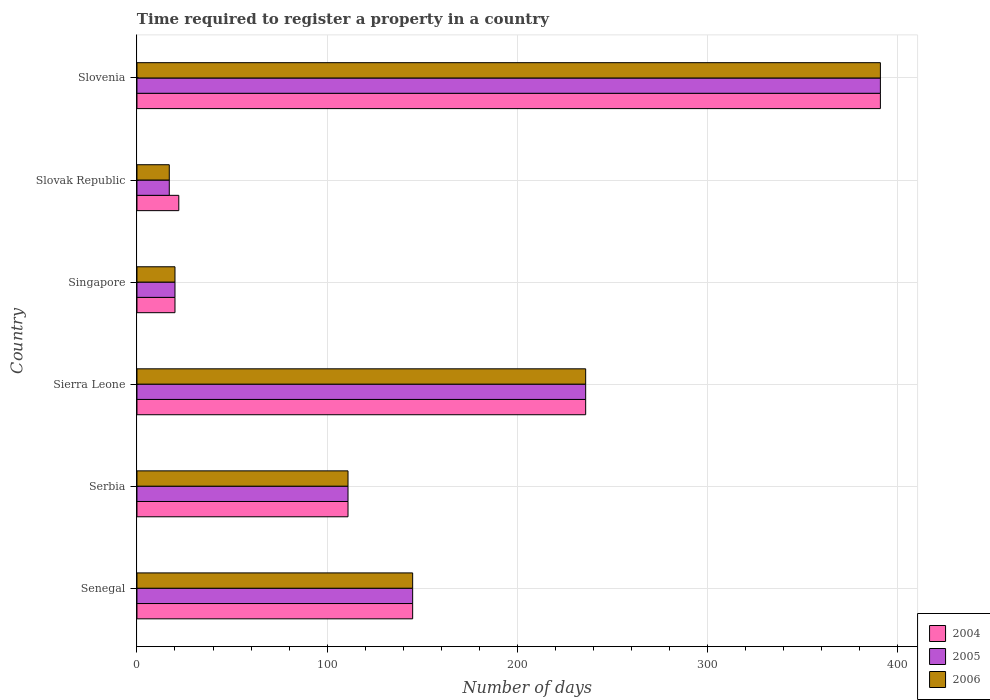Are the number of bars on each tick of the Y-axis equal?
Make the answer very short. Yes. How many bars are there on the 6th tick from the top?
Your response must be concise. 3. How many bars are there on the 3rd tick from the bottom?
Offer a very short reply. 3. What is the label of the 1st group of bars from the top?
Ensure brevity in your answer.  Slovenia. In how many cases, is the number of bars for a given country not equal to the number of legend labels?
Provide a short and direct response. 0. What is the number of days required to register a property in 2006 in Sierra Leone?
Provide a succinct answer. 236. Across all countries, what is the maximum number of days required to register a property in 2004?
Your answer should be very brief. 391. In which country was the number of days required to register a property in 2006 maximum?
Offer a terse response. Slovenia. In which country was the number of days required to register a property in 2005 minimum?
Your answer should be compact. Slovak Republic. What is the total number of days required to register a property in 2004 in the graph?
Your answer should be compact. 925. What is the difference between the number of days required to register a property in 2005 in Serbia and that in Slovenia?
Ensure brevity in your answer.  -280. What is the difference between the number of days required to register a property in 2005 in Serbia and the number of days required to register a property in 2004 in Senegal?
Give a very brief answer. -34. What is the average number of days required to register a property in 2004 per country?
Provide a short and direct response. 154.17. What is the ratio of the number of days required to register a property in 2004 in Sierra Leone to that in Slovenia?
Provide a short and direct response. 0.6. Is the number of days required to register a property in 2006 in Serbia less than that in Singapore?
Provide a short and direct response. No. Is the difference between the number of days required to register a property in 2006 in Singapore and Slovak Republic greater than the difference between the number of days required to register a property in 2004 in Singapore and Slovak Republic?
Ensure brevity in your answer.  Yes. What is the difference between the highest and the second highest number of days required to register a property in 2006?
Make the answer very short. 155. What is the difference between the highest and the lowest number of days required to register a property in 2004?
Provide a succinct answer. 371. In how many countries, is the number of days required to register a property in 2006 greater than the average number of days required to register a property in 2006 taken over all countries?
Your answer should be very brief. 2. Is the sum of the number of days required to register a property in 2006 in Serbia and Slovenia greater than the maximum number of days required to register a property in 2004 across all countries?
Keep it short and to the point. Yes. What does the 1st bar from the top in Slovak Republic represents?
Make the answer very short. 2006. Is it the case that in every country, the sum of the number of days required to register a property in 2004 and number of days required to register a property in 2006 is greater than the number of days required to register a property in 2005?
Make the answer very short. Yes. How many bars are there?
Your answer should be compact. 18. Are all the bars in the graph horizontal?
Offer a terse response. Yes. What is the difference between two consecutive major ticks on the X-axis?
Make the answer very short. 100. Does the graph contain any zero values?
Make the answer very short. No. Does the graph contain grids?
Your response must be concise. Yes. How many legend labels are there?
Your answer should be compact. 3. What is the title of the graph?
Keep it short and to the point. Time required to register a property in a country. Does "1973" appear as one of the legend labels in the graph?
Make the answer very short. No. What is the label or title of the X-axis?
Provide a short and direct response. Number of days. What is the label or title of the Y-axis?
Offer a very short reply. Country. What is the Number of days of 2004 in Senegal?
Offer a terse response. 145. What is the Number of days in 2005 in Senegal?
Provide a succinct answer. 145. What is the Number of days in 2006 in Senegal?
Your answer should be compact. 145. What is the Number of days of 2004 in Serbia?
Make the answer very short. 111. What is the Number of days of 2005 in Serbia?
Ensure brevity in your answer.  111. What is the Number of days of 2006 in Serbia?
Make the answer very short. 111. What is the Number of days of 2004 in Sierra Leone?
Your answer should be very brief. 236. What is the Number of days of 2005 in Sierra Leone?
Give a very brief answer. 236. What is the Number of days in 2006 in Sierra Leone?
Keep it short and to the point. 236. What is the Number of days in 2006 in Singapore?
Provide a succinct answer. 20. What is the Number of days in 2004 in Slovenia?
Provide a short and direct response. 391. What is the Number of days in 2005 in Slovenia?
Ensure brevity in your answer.  391. What is the Number of days in 2006 in Slovenia?
Your response must be concise. 391. Across all countries, what is the maximum Number of days of 2004?
Offer a terse response. 391. Across all countries, what is the maximum Number of days of 2005?
Make the answer very short. 391. Across all countries, what is the maximum Number of days in 2006?
Keep it short and to the point. 391. Across all countries, what is the minimum Number of days of 2004?
Provide a short and direct response. 20. What is the total Number of days of 2004 in the graph?
Offer a terse response. 925. What is the total Number of days in 2005 in the graph?
Offer a very short reply. 920. What is the total Number of days in 2006 in the graph?
Your response must be concise. 920. What is the difference between the Number of days in 2004 in Senegal and that in Serbia?
Ensure brevity in your answer.  34. What is the difference between the Number of days in 2004 in Senegal and that in Sierra Leone?
Your answer should be very brief. -91. What is the difference between the Number of days of 2005 in Senegal and that in Sierra Leone?
Your response must be concise. -91. What is the difference between the Number of days of 2006 in Senegal and that in Sierra Leone?
Offer a terse response. -91. What is the difference between the Number of days in 2004 in Senegal and that in Singapore?
Offer a terse response. 125. What is the difference between the Number of days of 2005 in Senegal and that in Singapore?
Offer a terse response. 125. What is the difference between the Number of days in 2006 in Senegal and that in Singapore?
Provide a succinct answer. 125. What is the difference between the Number of days of 2004 in Senegal and that in Slovak Republic?
Give a very brief answer. 123. What is the difference between the Number of days in 2005 in Senegal and that in Slovak Republic?
Give a very brief answer. 128. What is the difference between the Number of days in 2006 in Senegal and that in Slovak Republic?
Your answer should be compact. 128. What is the difference between the Number of days of 2004 in Senegal and that in Slovenia?
Make the answer very short. -246. What is the difference between the Number of days of 2005 in Senegal and that in Slovenia?
Ensure brevity in your answer.  -246. What is the difference between the Number of days of 2006 in Senegal and that in Slovenia?
Give a very brief answer. -246. What is the difference between the Number of days of 2004 in Serbia and that in Sierra Leone?
Your answer should be very brief. -125. What is the difference between the Number of days in 2005 in Serbia and that in Sierra Leone?
Your answer should be very brief. -125. What is the difference between the Number of days of 2006 in Serbia and that in Sierra Leone?
Your response must be concise. -125. What is the difference between the Number of days of 2004 in Serbia and that in Singapore?
Offer a terse response. 91. What is the difference between the Number of days of 2005 in Serbia and that in Singapore?
Offer a terse response. 91. What is the difference between the Number of days of 2006 in Serbia and that in Singapore?
Ensure brevity in your answer.  91. What is the difference between the Number of days of 2004 in Serbia and that in Slovak Republic?
Give a very brief answer. 89. What is the difference between the Number of days in 2005 in Serbia and that in Slovak Republic?
Your answer should be very brief. 94. What is the difference between the Number of days in 2006 in Serbia and that in Slovak Republic?
Provide a succinct answer. 94. What is the difference between the Number of days in 2004 in Serbia and that in Slovenia?
Provide a short and direct response. -280. What is the difference between the Number of days of 2005 in Serbia and that in Slovenia?
Give a very brief answer. -280. What is the difference between the Number of days in 2006 in Serbia and that in Slovenia?
Your response must be concise. -280. What is the difference between the Number of days of 2004 in Sierra Leone and that in Singapore?
Provide a short and direct response. 216. What is the difference between the Number of days of 2005 in Sierra Leone and that in Singapore?
Give a very brief answer. 216. What is the difference between the Number of days of 2006 in Sierra Leone and that in Singapore?
Give a very brief answer. 216. What is the difference between the Number of days in 2004 in Sierra Leone and that in Slovak Republic?
Your answer should be compact. 214. What is the difference between the Number of days in 2005 in Sierra Leone and that in Slovak Republic?
Your answer should be compact. 219. What is the difference between the Number of days of 2006 in Sierra Leone and that in Slovak Republic?
Give a very brief answer. 219. What is the difference between the Number of days of 2004 in Sierra Leone and that in Slovenia?
Your answer should be compact. -155. What is the difference between the Number of days in 2005 in Sierra Leone and that in Slovenia?
Ensure brevity in your answer.  -155. What is the difference between the Number of days of 2006 in Sierra Leone and that in Slovenia?
Ensure brevity in your answer.  -155. What is the difference between the Number of days in 2004 in Singapore and that in Slovak Republic?
Provide a succinct answer. -2. What is the difference between the Number of days of 2005 in Singapore and that in Slovak Republic?
Provide a succinct answer. 3. What is the difference between the Number of days of 2004 in Singapore and that in Slovenia?
Your response must be concise. -371. What is the difference between the Number of days in 2005 in Singapore and that in Slovenia?
Offer a very short reply. -371. What is the difference between the Number of days of 2006 in Singapore and that in Slovenia?
Give a very brief answer. -371. What is the difference between the Number of days of 2004 in Slovak Republic and that in Slovenia?
Provide a succinct answer. -369. What is the difference between the Number of days in 2005 in Slovak Republic and that in Slovenia?
Provide a succinct answer. -374. What is the difference between the Number of days of 2006 in Slovak Republic and that in Slovenia?
Give a very brief answer. -374. What is the difference between the Number of days of 2004 in Senegal and the Number of days of 2005 in Sierra Leone?
Give a very brief answer. -91. What is the difference between the Number of days of 2004 in Senegal and the Number of days of 2006 in Sierra Leone?
Your answer should be compact. -91. What is the difference between the Number of days of 2005 in Senegal and the Number of days of 2006 in Sierra Leone?
Keep it short and to the point. -91. What is the difference between the Number of days of 2004 in Senegal and the Number of days of 2005 in Singapore?
Your response must be concise. 125. What is the difference between the Number of days of 2004 in Senegal and the Number of days of 2006 in Singapore?
Give a very brief answer. 125. What is the difference between the Number of days in 2005 in Senegal and the Number of days in 2006 in Singapore?
Your answer should be compact. 125. What is the difference between the Number of days in 2004 in Senegal and the Number of days in 2005 in Slovak Republic?
Your answer should be compact. 128. What is the difference between the Number of days of 2004 in Senegal and the Number of days of 2006 in Slovak Republic?
Make the answer very short. 128. What is the difference between the Number of days in 2005 in Senegal and the Number of days in 2006 in Slovak Republic?
Your answer should be very brief. 128. What is the difference between the Number of days in 2004 in Senegal and the Number of days in 2005 in Slovenia?
Your answer should be very brief. -246. What is the difference between the Number of days of 2004 in Senegal and the Number of days of 2006 in Slovenia?
Your answer should be very brief. -246. What is the difference between the Number of days in 2005 in Senegal and the Number of days in 2006 in Slovenia?
Your answer should be compact. -246. What is the difference between the Number of days in 2004 in Serbia and the Number of days in 2005 in Sierra Leone?
Your response must be concise. -125. What is the difference between the Number of days in 2004 in Serbia and the Number of days in 2006 in Sierra Leone?
Your response must be concise. -125. What is the difference between the Number of days in 2005 in Serbia and the Number of days in 2006 in Sierra Leone?
Offer a terse response. -125. What is the difference between the Number of days in 2004 in Serbia and the Number of days in 2005 in Singapore?
Provide a short and direct response. 91. What is the difference between the Number of days of 2004 in Serbia and the Number of days of 2006 in Singapore?
Provide a succinct answer. 91. What is the difference between the Number of days in 2005 in Serbia and the Number of days in 2006 in Singapore?
Provide a short and direct response. 91. What is the difference between the Number of days of 2004 in Serbia and the Number of days of 2005 in Slovak Republic?
Give a very brief answer. 94. What is the difference between the Number of days in 2004 in Serbia and the Number of days in 2006 in Slovak Republic?
Keep it short and to the point. 94. What is the difference between the Number of days in 2005 in Serbia and the Number of days in 2006 in Slovak Republic?
Give a very brief answer. 94. What is the difference between the Number of days in 2004 in Serbia and the Number of days in 2005 in Slovenia?
Provide a short and direct response. -280. What is the difference between the Number of days in 2004 in Serbia and the Number of days in 2006 in Slovenia?
Your answer should be very brief. -280. What is the difference between the Number of days in 2005 in Serbia and the Number of days in 2006 in Slovenia?
Give a very brief answer. -280. What is the difference between the Number of days in 2004 in Sierra Leone and the Number of days in 2005 in Singapore?
Your answer should be compact. 216. What is the difference between the Number of days of 2004 in Sierra Leone and the Number of days of 2006 in Singapore?
Offer a terse response. 216. What is the difference between the Number of days in 2005 in Sierra Leone and the Number of days in 2006 in Singapore?
Make the answer very short. 216. What is the difference between the Number of days in 2004 in Sierra Leone and the Number of days in 2005 in Slovak Republic?
Make the answer very short. 219. What is the difference between the Number of days of 2004 in Sierra Leone and the Number of days of 2006 in Slovak Republic?
Ensure brevity in your answer.  219. What is the difference between the Number of days of 2005 in Sierra Leone and the Number of days of 2006 in Slovak Republic?
Make the answer very short. 219. What is the difference between the Number of days of 2004 in Sierra Leone and the Number of days of 2005 in Slovenia?
Keep it short and to the point. -155. What is the difference between the Number of days in 2004 in Sierra Leone and the Number of days in 2006 in Slovenia?
Provide a short and direct response. -155. What is the difference between the Number of days of 2005 in Sierra Leone and the Number of days of 2006 in Slovenia?
Keep it short and to the point. -155. What is the difference between the Number of days of 2005 in Singapore and the Number of days of 2006 in Slovak Republic?
Your response must be concise. 3. What is the difference between the Number of days of 2004 in Singapore and the Number of days of 2005 in Slovenia?
Give a very brief answer. -371. What is the difference between the Number of days of 2004 in Singapore and the Number of days of 2006 in Slovenia?
Your answer should be compact. -371. What is the difference between the Number of days of 2005 in Singapore and the Number of days of 2006 in Slovenia?
Offer a very short reply. -371. What is the difference between the Number of days in 2004 in Slovak Republic and the Number of days in 2005 in Slovenia?
Provide a short and direct response. -369. What is the difference between the Number of days of 2004 in Slovak Republic and the Number of days of 2006 in Slovenia?
Keep it short and to the point. -369. What is the difference between the Number of days of 2005 in Slovak Republic and the Number of days of 2006 in Slovenia?
Your answer should be very brief. -374. What is the average Number of days of 2004 per country?
Provide a short and direct response. 154.17. What is the average Number of days of 2005 per country?
Offer a terse response. 153.33. What is the average Number of days in 2006 per country?
Your answer should be very brief. 153.33. What is the difference between the Number of days of 2004 and Number of days of 2005 in Senegal?
Offer a terse response. 0. What is the difference between the Number of days of 2004 and Number of days of 2006 in Senegal?
Ensure brevity in your answer.  0. What is the difference between the Number of days of 2005 and Number of days of 2006 in Senegal?
Provide a succinct answer. 0. What is the difference between the Number of days of 2005 and Number of days of 2006 in Sierra Leone?
Provide a succinct answer. 0. What is the difference between the Number of days in 2004 and Number of days in 2005 in Singapore?
Your answer should be compact. 0. What is the difference between the Number of days in 2004 and Number of days in 2006 in Singapore?
Give a very brief answer. 0. What is the difference between the Number of days in 2004 and Number of days in 2006 in Slovak Republic?
Your answer should be very brief. 5. What is the difference between the Number of days in 2005 and Number of days in 2006 in Slovak Republic?
Make the answer very short. 0. What is the difference between the Number of days in 2004 and Number of days in 2005 in Slovenia?
Offer a terse response. 0. What is the difference between the Number of days of 2004 and Number of days of 2006 in Slovenia?
Provide a short and direct response. 0. What is the ratio of the Number of days in 2004 in Senegal to that in Serbia?
Your answer should be compact. 1.31. What is the ratio of the Number of days of 2005 in Senegal to that in Serbia?
Offer a terse response. 1.31. What is the ratio of the Number of days of 2006 in Senegal to that in Serbia?
Ensure brevity in your answer.  1.31. What is the ratio of the Number of days of 2004 in Senegal to that in Sierra Leone?
Give a very brief answer. 0.61. What is the ratio of the Number of days in 2005 in Senegal to that in Sierra Leone?
Your response must be concise. 0.61. What is the ratio of the Number of days of 2006 in Senegal to that in Sierra Leone?
Your response must be concise. 0.61. What is the ratio of the Number of days of 2004 in Senegal to that in Singapore?
Offer a very short reply. 7.25. What is the ratio of the Number of days in 2005 in Senegal to that in Singapore?
Your response must be concise. 7.25. What is the ratio of the Number of days in 2006 in Senegal to that in Singapore?
Offer a terse response. 7.25. What is the ratio of the Number of days in 2004 in Senegal to that in Slovak Republic?
Your answer should be compact. 6.59. What is the ratio of the Number of days of 2005 in Senegal to that in Slovak Republic?
Provide a short and direct response. 8.53. What is the ratio of the Number of days of 2006 in Senegal to that in Slovak Republic?
Provide a succinct answer. 8.53. What is the ratio of the Number of days of 2004 in Senegal to that in Slovenia?
Provide a succinct answer. 0.37. What is the ratio of the Number of days in 2005 in Senegal to that in Slovenia?
Give a very brief answer. 0.37. What is the ratio of the Number of days of 2006 in Senegal to that in Slovenia?
Give a very brief answer. 0.37. What is the ratio of the Number of days in 2004 in Serbia to that in Sierra Leone?
Your answer should be compact. 0.47. What is the ratio of the Number of days in 2005 in Serbia to that in Sierra Leone?
Offer a very short reply. 0.47. What is the ratio of the Number of days in 2006 in Serbia to that in Sierra Leone?
Give a very brief answer. 0.47. What is the ratio of the Number of days in 2004 in Serbia to that in Singapore?
Keep it short and to the point. 5.55. What is the ratio of the Number of days of 2005 in Serbia to that in Singapore?
Make the answer very short. 5.55. What is the ratio of the Number of days in 2006 in Serbia to that in Singapore?
Your answer should be very brief. 5.55. What is the ratio of the Number of days of 2004 in Serbia to that in Slovak Republic?
Offer a very short reply. 5.05. What is the ratio of the Number of days in 2005 in Serbia to that in Slovak Republic?
Provide a succinct answer. 6.53. What is the ratio of the Number of days of 2006 in Serbia to that in Slovak Republic?
Provide a succinct answer. 6.53. What is the ratio of the Number of days of 2004 in Serbia to that in Slovenia?
Your response must be concise. 0.28. What is the ratio of the Number of days in 2005 in Serbia to that in Slovenia?
Give a very brief answer. 0.28. What is the ratio of the Number of days in 2006 in Serbia to that in Slovenia?
Provide a short and direct response. 0.28. What is the ratio of the Number of days in 2004 in Sierra Leone to that in Singapore?
Provide a short and direct response. 11.8. What is the ratio of the Number of days in 2005 in Sierra Leone to that in Singapore?
Provide a succinct answer. 11.8. What is the ratio of the Number of days of 2004 in Sierra Leone to that in Slovak Republic?
Offer a terse response. 10.73. What is the ratio of the Number of days in 2005 in Sierra Leone to that in Slovak Republic?
Your answer should be compact. 13.88. What is the ratio of the Number of days of 2006 in Sierra Leone to that in Slovak Republic?
Your answer should be very brief. 13.88. What is the ratio of the Number of days in 2004 in Sierra Leone to that in Slovenia?
Your answer should be compact. 0.6. What is the ratio of the Number of days of 2005 in Sierra Leone to that in Slovenia?
Your answer should be compact. 0.6. What is the ratio of the Number of days of 2006 in Sierra Leone to that in Slovenia?
Keep it short and to the point. 0.6. What is the ratio of the Number of days of 2005 in Singapore to that in Slovak Republic?
Ensure brevity in your answer.  1.18. What is the ratio of the Number of days in 2006 in Singapore to that in Slovak Republic?
Make the answer very short. 1.18. What is the ratio of the Number of days in 2004 in Singapore to that in Slovenia?
Make the answer very short. 0.05. What is the ratio of the Number of days of 2005 in Singapore to that in Slovenia?
Make the answer very short. 0.05. What is the ratio of the Number of days of 2006 in Singapore to that in Slovenia?
Your answer should be very brief. 0.05. What is the ratio of the Number of days of 2004 in Slovak Republic to that in Slovenia?
Offer a very short reply. 0.06. What is the ratio of the Number of days in 2005 in Slovak Republic to that in Slovenia?
Give a very brief answer. 0.04. What is the ratio of the Number of days in 2006 in Slovak Republic to that in Slovenia?
Keep it short and to the point. 0.04. What is the difference between the highest and the second highest Number of days of 2004?
Make the answer very short. 155. What is the difference between the highest and the second highest Number of days in 2005?
Your answer should be very brief. 155. What is the difference between the highest and the second highest Number of days of 2006?
Your answer should be very brief. 155. What is the difference between the highest and the lowest Number of days in 2004?
Ensure brevity in your answer.  371. What is the difference between the highest and the lowest Number of days of 2005?
Your response must be concise. 374. What is the difference between the highest and the lowest Number of days of 2006?
Offer a terse response. 374. 